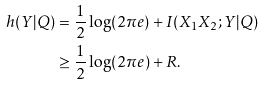Convert formula to latex. <formula><loc_0><loc_0><loc_500><loc_500>h ( Y | Q ) & = \frac { 1 } { 2 } \log ( 2 \pi e ) + I ( X _ { 1 } X _ { 2 } ; Y | Q ) \\ & \geq \frac { 1 } { 2 } \log ( 2 \pi e ) + R .</formula> 